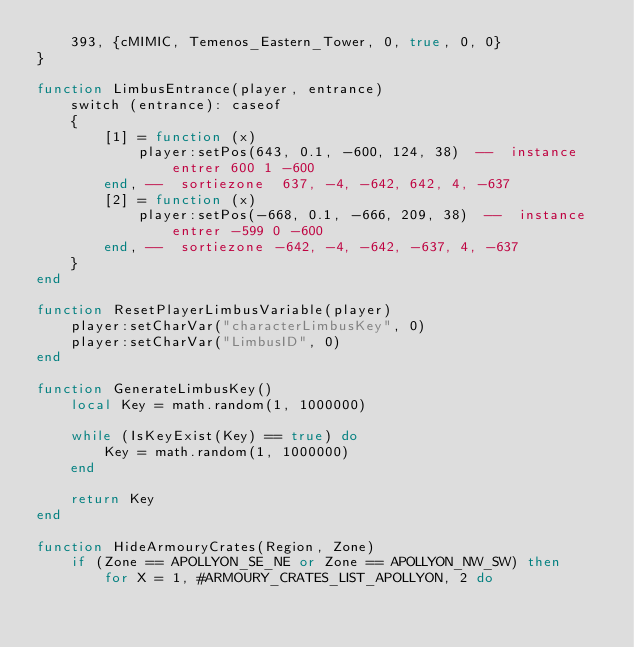Convert code to text. <code><loc_0><loc_0><loc_500><loc_500><_Lua_>    393, {cMIMIC, Temenos_Eastern_Tower, 0, true, 0, 0}
}

function LimbusEntrance(player, entrance)
    switch (entrance): caseof
    {
        [1] = function (x)
            player:setPos(643, 0.1, -600, 124, 38)  --  instance entrer 600 1 -600
        end, --  sortiezone  637, -4, -642, 642, 4, -637
        [2] = function (x)
            player:setPos(-668, 0.1, -666, 209, 38)  --  instance entrer -599 0 -600
        end, --  sortiezone -642, -4, -642, -637, 4, -637
    }
end

function ResetPlayerLimbusVariable(player)
    player:setCharVar("characterLimbusKey", 0)
    player:setCharVar("LimbusID", 0)
end

function GenerateLimbusKey()
    local Key = math.random(1, 1000000)

    while (IsKeyExist(Key) == true) do
        Key = math.random(1, 1000000)
    end

    return Key
end

function HideArmouryCrates(Region, Zone)
    if (Zone == APOLLYON_SE_NE or Zone == APOLLYON_NW_SW) then
        for X = 1, #ARMOURY_CRATES_LIST_APOLLYON, 2 do</code> 